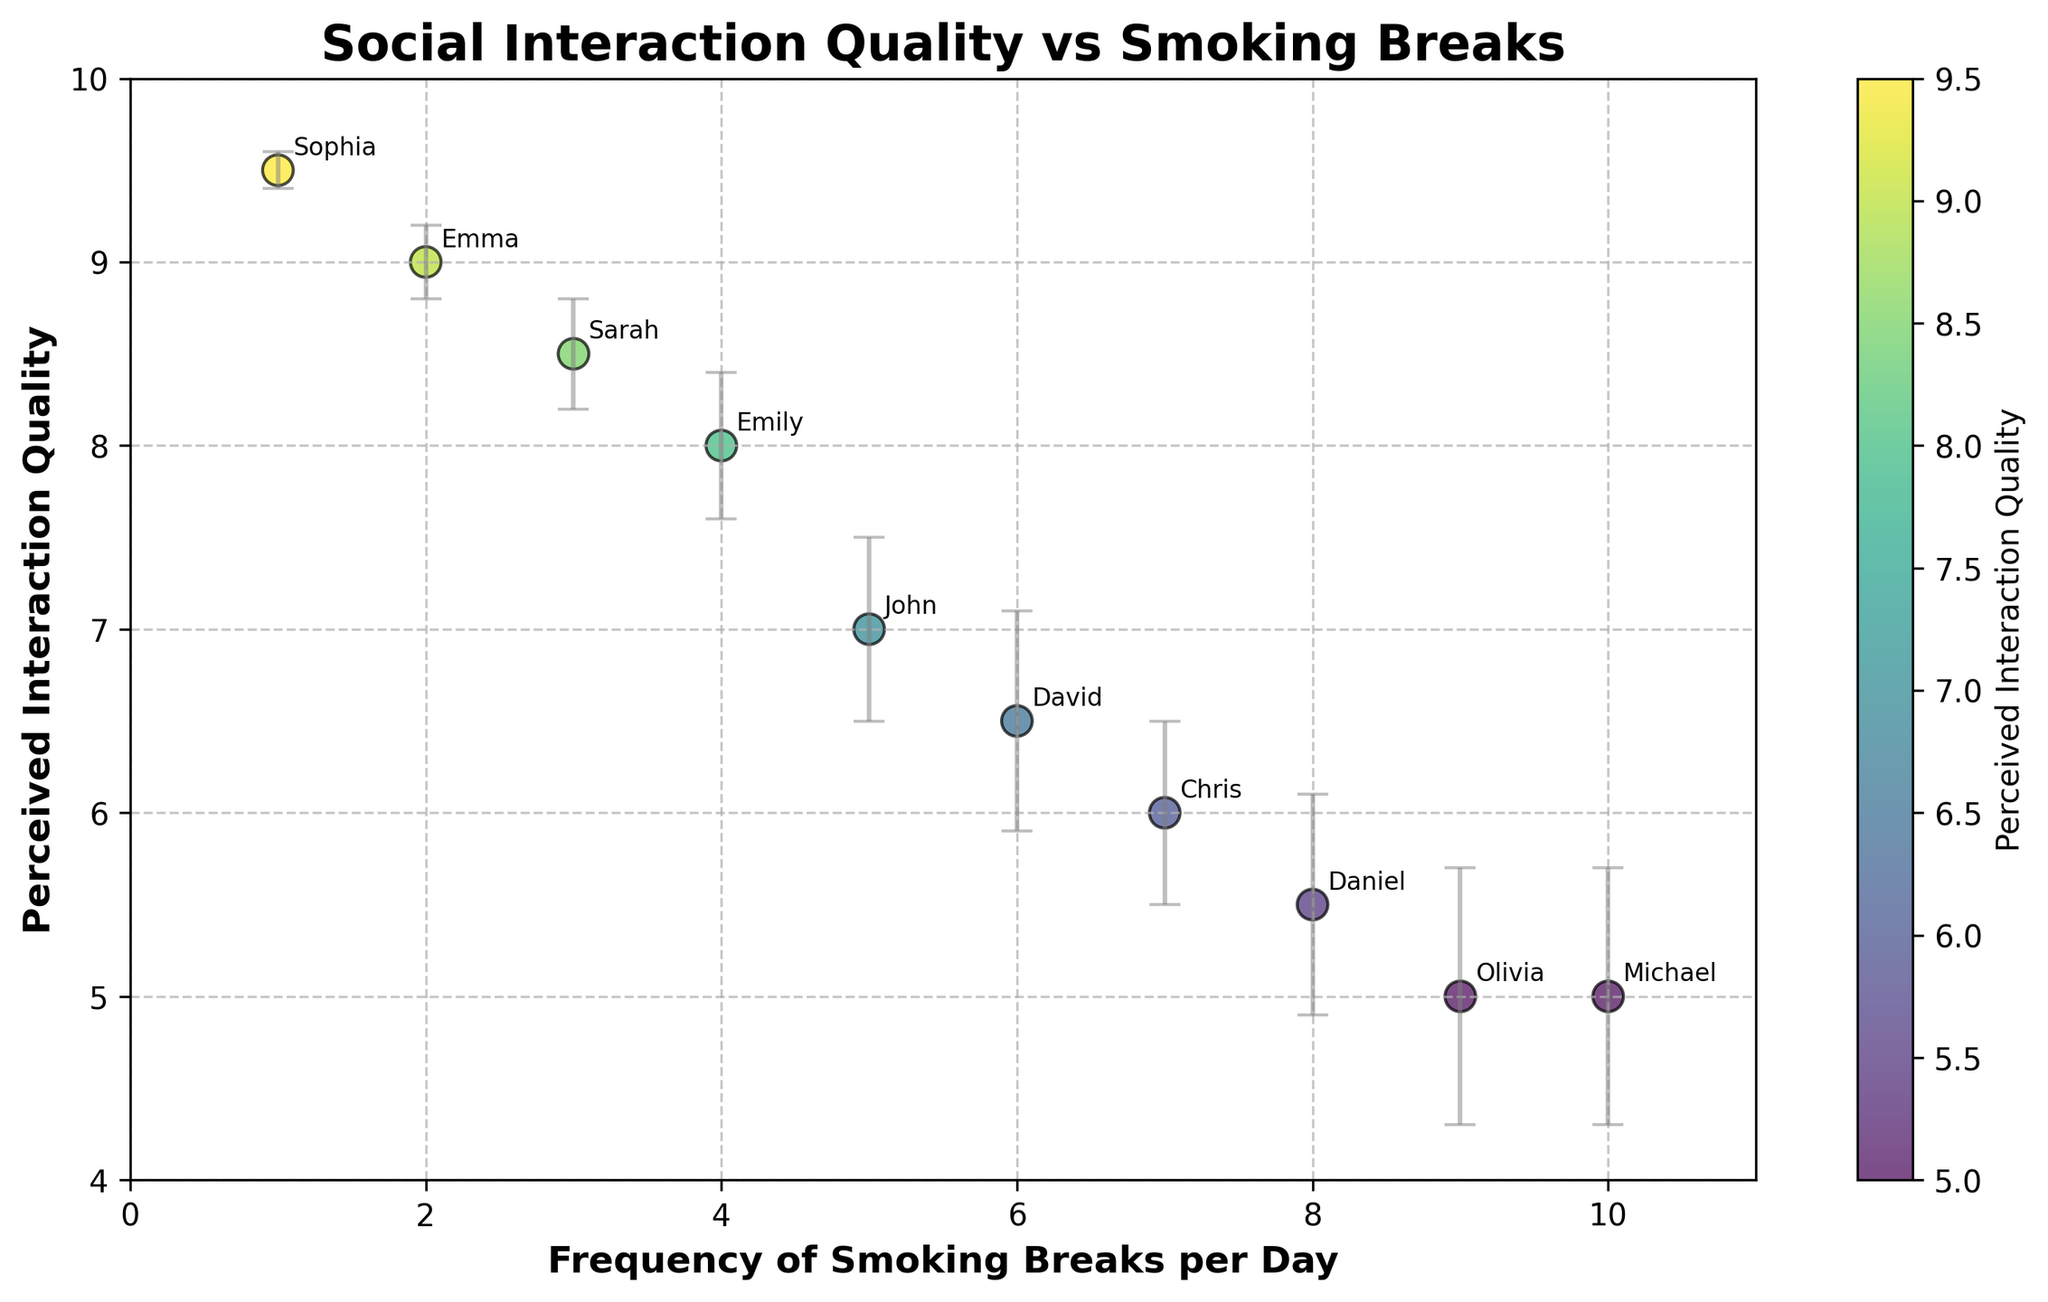What's the title of the figure? The title of the figure is usually displayed at the top center. In this figure, it reads "Social Interaction Quality vs Smoking Breaks."
Answer: Social Interaction Quality vs Smoking Breaks How many data points are there in the figure? Count the number of unique names annotated in the figure. Each name represents a data point. The figure has annotations for John, Emily, Michael, Sarah, David, Emma, Chris, Sophia, Daniel, and Olivia, making a total of 10 data points.
Answer: 10 Who has the highest perceived interaction quality? Look at the y-axis and identify the highest data point. The highest perceived interaction quality is annotated as Sophia, who has a score of 9.5.
Answer: Sophia What is the range of the frequency of smoking breaks per day? Identify the lowest and highest values on the x-axis. The lowest value is 1 (Sophia) and the highest value is 10 (Michael), so the range is 1 to 10 breaks per day.
Answer: 1 to 10 What is the perceived interaction quality of the person with the lowest frequency of smoking breaks? Identify the data point with the lowest x-axis value (1 for Sophia). The corresponding y-axis value indicates the perceived interaction quality, which is 9.5.
Answer: 9.5 How many people have a perceived interaction quality of 8 or higher? Examine the y-axis and count the number of data points where the value is 8 or above. The individuals are Emily (8), Sarah (8.5), Emma (9), and Sophia (9.5), totaling 4 people.
Answer: 4 What is the difference in perceived interaction quality between the person who takes the most breaks and the person who takes the fewest breaks? The person taking the most breaks is Michael (10 breaks, quality: 5), and the person taking the fewest breaks is Sophia (1 break, quality: 9.5). The difference is 9.5 - 5 = 4.5.
Answer: 4.5 Who has the largest error bar in their perceived interaction quality? Compare the length of error bars for each data point. Michael and Olivia both have the largest error bars, which is 0.7.
Answer: Michael and Olivia Is there a general trend between the frequency of smoking breaks and perceived interaction quality? Observe the overall scattering of the data points. There appears to be a negative trend, where increased frequency of smoking breaks corresponds to lower perceived interaction quality.
Answer: Negative trend What is the average perceived interaction quality for people who take more than 5 breaks per day? Identify data points with more than 5 breaks: Michael (5), David (6.5), Chris (6), Daniel (5.5), Olivia (5). Average = (5 + 6.5 + 6 + 5.5 + 5)/5 = 28/5 = 5.6.
Answer: 5.6 